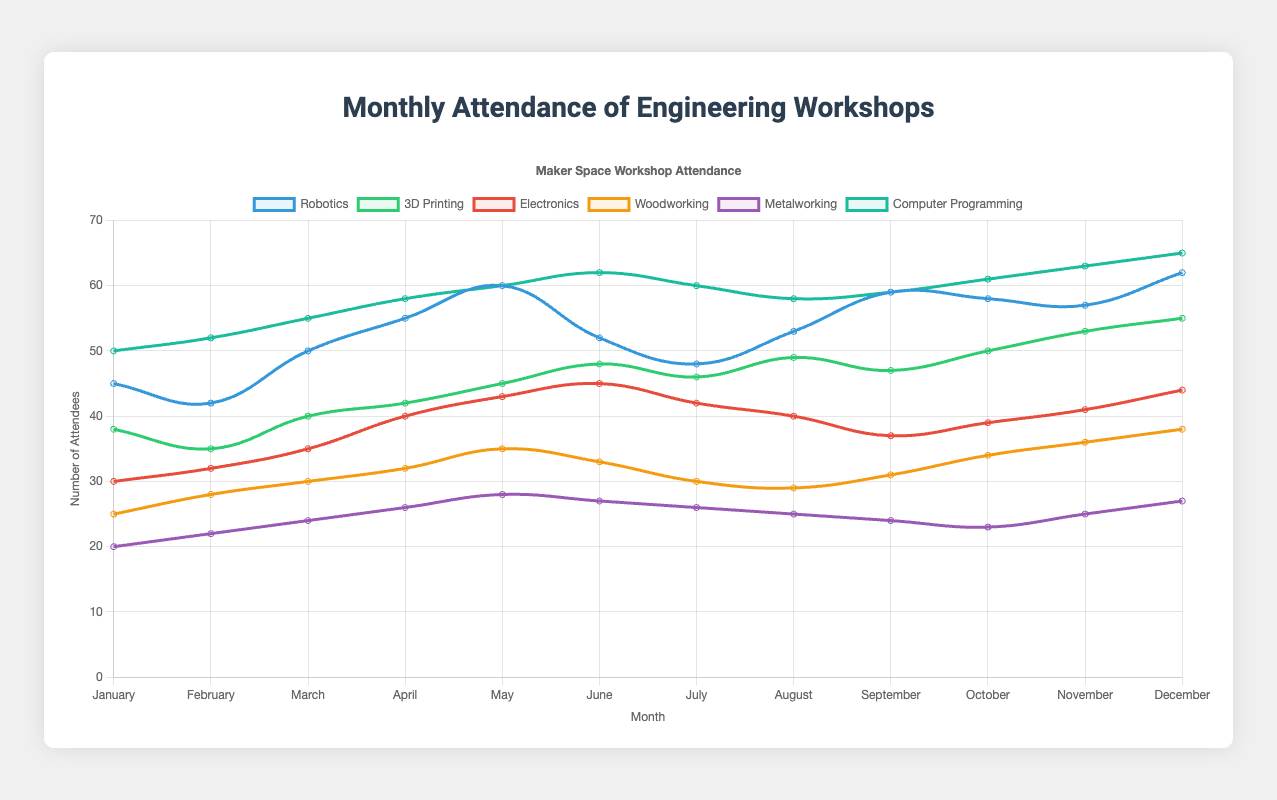What month had the highest attendance for Robotics workshops? Refer to the Robotics line; the highest point on the chart for Robotics is in December with 62 attendees
Answer: December Which workshop had the highest attendance in July? Look at the lines corresponding to each discipline in the month of July; Computer Programming has the highest point with 60 attendees
Answer: Computer Programming What is the total attendance for Electronics workshops from January to March? Sum the values for Electronics from January to March: 30 + 32 + 35 = 97
Answer: 97 Which discipline had the lowest average attendance over the year? Calculate the average attendance for each discipline; Metalworking has: (20+22+24+26+28+27+26+25+24+23+25+27)/12 = 24.5, which is the lowest
Answer: Metalworking Is the attendance for 3D Printing workshops generally increasing or decreasing over the year? Observe the trend of the 3D Printing line; the line generally increases from 38 in January to 55 in December
Answer: Increasing What is the difference in attendance between Robotics and Woodworking in May? Find the values for May: Robotics has 60 and Woodworking has 35; the difference is 60 - 35 = 25
Answer: 25 Which month showed the highest increase in attendance for Computer Programming compared to the previous month? Compare the differences month by month for Computer Programming: the highest increase is from May (60) to June (62), with an increase of 2
Answer: June What is the average attendance for all workshops in June? Sum the June values for each discipline and divide by the number of disciplines: (52 + 48 + 45 + 33 + 27 + 62) / 6 = 44.5
Answer: 44.5 How does the attendance of Electronics workshops in April compare to that in October? Compare the values for Electronics in April (40) and October (39); April has 1 more attendee than October
Answer: April has 1 more What is the total attendance for Woodworking and Metalworking combined in December? Sum the December values for both Woodworking and Metalworking: 38 + 27 = 65
Answer: 65 